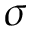<formula> <loc_0><loc_0><loc_500><loc_500>\sigma</formula> 